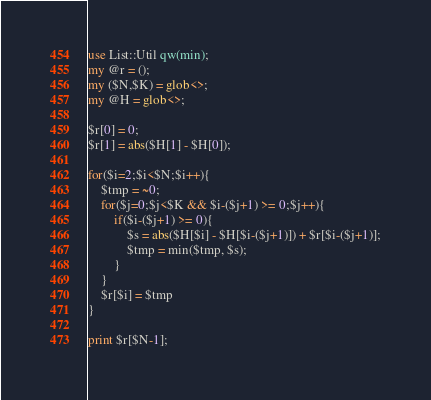<code> <loc_0><loc_0><loc_500><loc_500><_Perl_>use List::Util qw(min);
my @r = ();
my ($N,$K) = glob<>;
my @H = glob<>;

$r[0] = 0;
$r[1] = abs($H[1] - $H[0]);

for($i=2;$i<$N;$i++){
    $tmp = ~0;
    for($j=0;$j<$K && $i-($j+1) >= 0;$j++){
        if($i-($j+1) >= 0){
            $s = abs($H[$i] - $H[$i-($j+1)]) + $r[$i-($j+1)];
            $tmp = min($tmp, $s);
        }
    }
    $r[$i] = $tmp
}

print $r[$N-1];</code> 